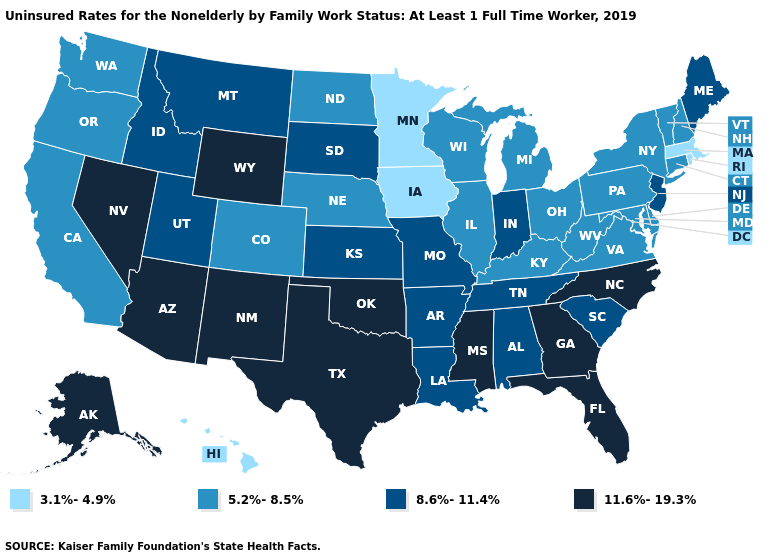Does the map have missing data?
Be succinct. No. Among the states that border Arkansas , which have the highest value?
Be succinct. Mississippi, Oklahoma, Texas. What is the lowest value in the USA?
Be succinct. 3.1%-4.9%. Is the legend a continuous bar?
Be succinct. No. Does the first symbol in the legend represent the smallest category?
Be succinct. Yes. What is the value of New York?
Be succinct. 5.2%-8.5%. Which states have the lowest value in the West?
Short answer required. Hawaii. Name the states that have a value in the range 5.2%-8.5%?
Short answer required. California, Colorado, Connecticut, Delaware, Illinois, Kentucky, Maryland, Michigan, Nebraska, New Hampshire, New York, North Dakota, Ohio, Oregon, Pennsylvania, Vermont, Virginia, Washington, West Virginia, Wisconsin. What is the value of Indiana?
Give a very brief answer. 8.6%-11.4%. Does the first symbol in the legend represent the smallest category?
Concise answer only. Yes. What is the highest value in states that border Missouri?
Concise answer only. 11.6%-19.3%. Does New Hampshire have the highest value in the USA?
Keep it brief. No. What is the highest value in states that border Massachusetts?
Short answer required. 5.2%-8.5%. Which states have the lowest value in the USA?
Short answer required. Hawaii, Iowa, Massachusetts, Minnesota, Rhode Island. Which states hav the highest value in the West?
Write a very short answer. Alaska, Arizona, Nevada, New Mexico, Wyoming. 